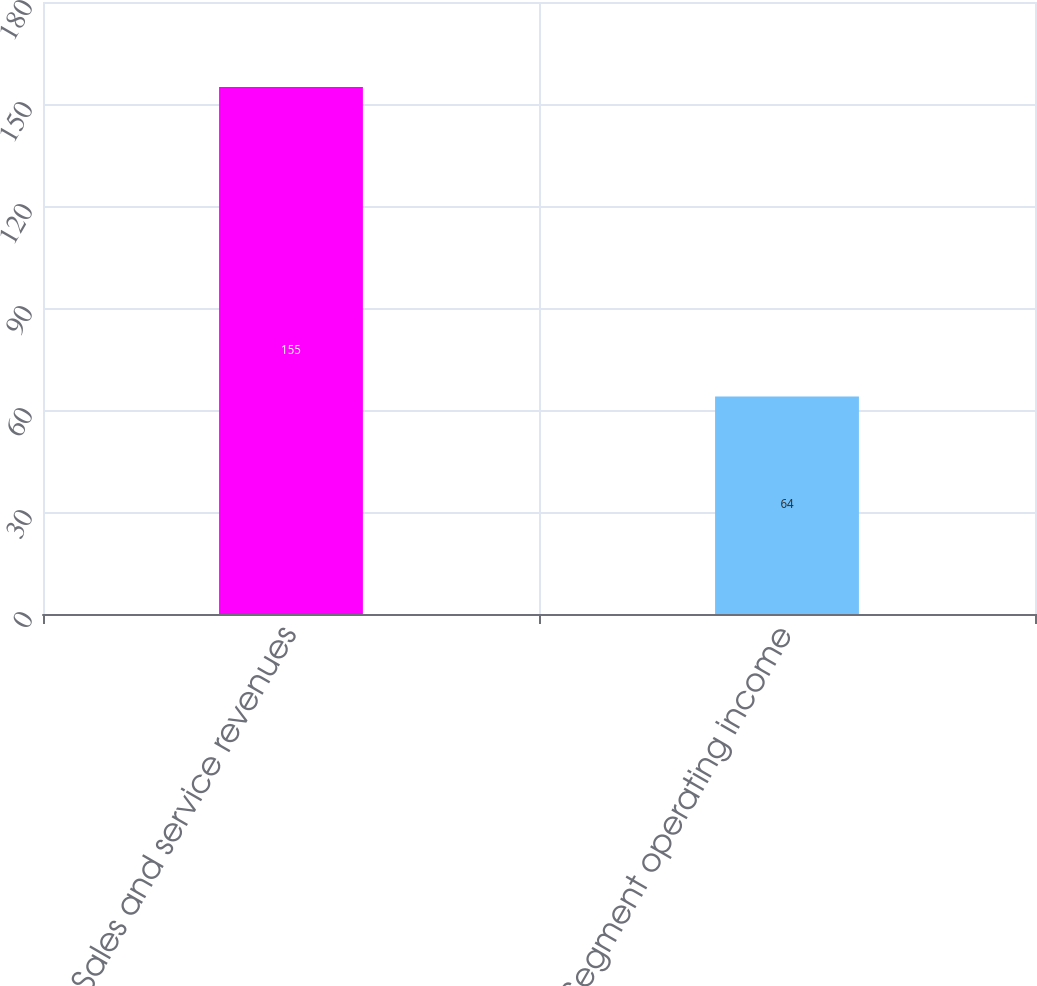<chart> <loc_0><loc_0><loc_500><loc_500><bar_chart><fcel>Sales and service revenues<fcel>Segment operating income<nl><fcel>155<fcel>64<nl></chart> 